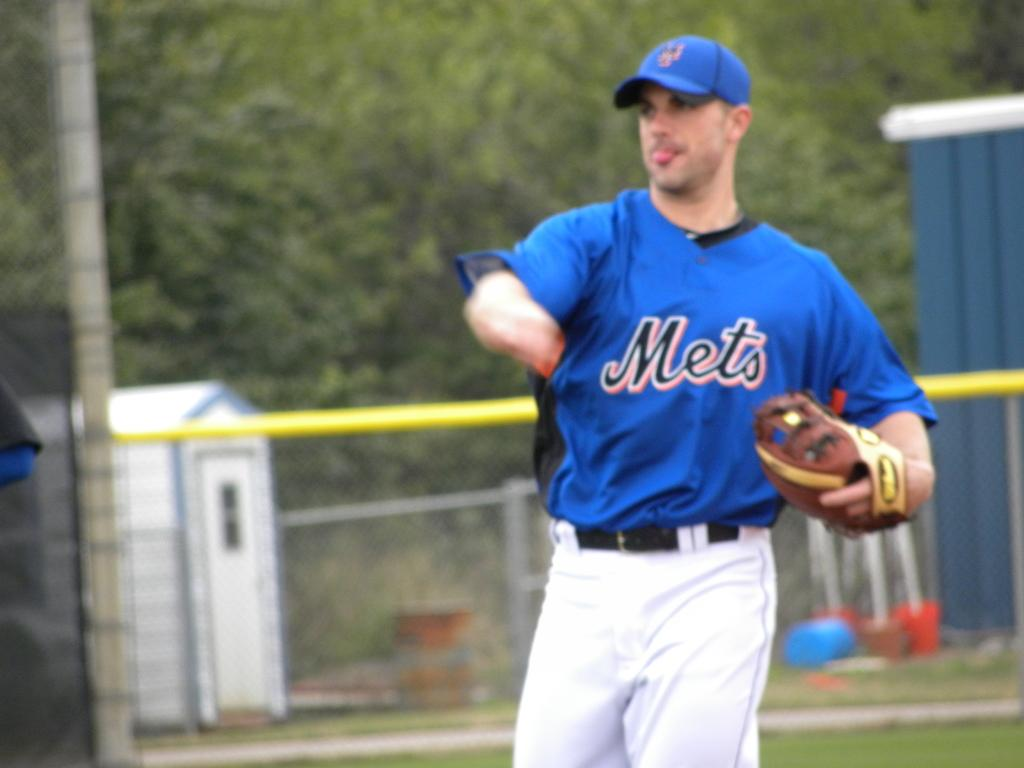<image>
Provide a brief description of the given image. A ball player pitches for the Mets on the field. 